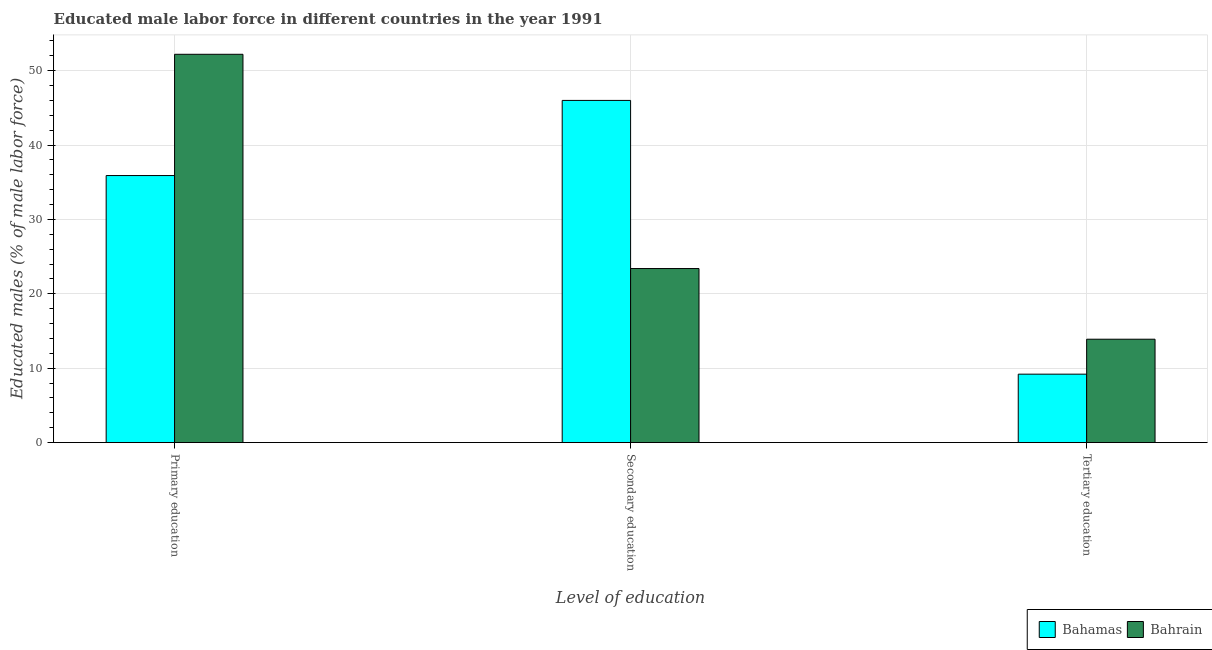How many groups of bars are there?
Ensure brevity in your answer.  3. Are the number of bars on each tick of the X-axis equal?
Make the answer very short. Yes. What is the label of the 3rd group of bars from the left?
Ensure brevity in your answer.  Tertiary education. What is the percentage of male labor force who received secondary education in Bahrain?
Keep it short and to the point. 23.4. Across all countries, what is the maximum percentage of male labor force who received tertiary education?
Your response must be concise. 13.9. Across all countries, what is the minimum percentage of male labor force who received primary education?
Your response must be concise. 35.9. In which country was the percentage of male labor force who received tertiary education maximum?
Ensure brevity in your answer.  Bahrain. In which country was the percentage of male labor force who received primary education minimum?
Your answer should be compact. Bahamas. What is the total percentage of male labor force who received primary education in the graph?
Make the answer very short. 88.1. What is the difference between the percentage of male labor force who received primary education in Bahrain and that in Bahamas?
Your response must be concise. 16.3. What is the difference between the percentage of male labor force who received secondary education in Bahamas and the percentage of male labor force who received tertiary education in Bahrain?
Provide a short and direct response. 32.1. What is the average percentage of male labor force who received primary education per country?
Your answer should be very brief. 44.05. What is the difference between the percentage of male labor force who received tertiary education and percentage of male labor force who received primary education in Bahamas?
Provide a succinct answer. -26.7. In how many countries, is the percentage of male labor force who received tertiary education greater than 46 %?
Give a very brief answer. 0. What is the ratio of the percentage of male labor force who received tertiary education in Bahamas to that in Bahrain?
Your answer should be very brief. 0.66. Is the percentage of male labor force who received secondary education in Bahrain less than that in Bahamas?
Provide a short and direct response. Yes. Is the difference between the percentage of male labor force who received primary education in Bahamas and Bahrain greater than the difference between the percentage of male labor force who received secondary education in Bahamas and Bahrain?
Your answer should be very brief. No. What is the difference between the highest and the second highest percentage of male labor force who received secondary education?
Give a very brief answer. 22.6. What is the difference between the highest and the lowest percentage of male labor force who received secondary education?
Keep it short and to the point. 22.6. What does the 2nd bar from the left in Primary education represents?
Keep it short and to the point. Bahrain. What does the 1st bar from the right in Secondary education represents?
Give a very brief answer. Bahrain. Is it the case that in every country, the sum of the percentage of male labor force who received primary education and percentage of male labor force who received secondary education is greater than the percentage of male labor force who received tertiary education?
Your answer should be very brief. Yes. How many bars are there?
Provide a succinct answer. 6. What is the difference between two consecutive major ticks on the Y-axis?
Offer a terse response. 10. Where does the legend appear in the graph?
Ensure brevity in your answer.  Bottom right. How are the legend labels stacked?
Your response must be concise. Horizontal. What is the title of the graph?
Provide a short and direct response. Educated male labor force in different countries in the year 1991. Does "Sweden" appear as one of the legend labels in the graph?
Offer a terse response. No. What is the label or title of the X-axis?
Your answer should be compact. Level of education. What is the label or title of the Y-axis?
Make the answer very short. Educated males (% of male labor force). What is the Educated males (% of male labor force) in Bahamas in Primary education?
Provide a short and direct response. 35.9. What is the Educated males (% of male labor force) in Bahrain in Primary education?
Offer a very short reply. 52.2. What is the Educated males (% of male labor force) of Bahrain in Secondary education?
Make the answer very short. 23.4. What is the Educated males (% of male labor force) in Bahamas in Tertiary education?
Your answer should be very brief. 9.2. What is the Educated males (% of male labor force) of Bahrain in Tertiary education?
Keep it short and to the point. 13.9. Across all Level of education, what is the maximum Educated males (% of male labor force) of Bahrain?
Offer a very short reply. 52.2. Across all Level of education, what is the minimum Educated males (% of male labor force) of Bahamas?
Provide a short and direct response. 9.2. Across all Level of education, what is the minimum Educated males (% of male labor force) of Bahrain?
Your answer should be very brief. 13.9. What is the total Educated males (% of male labor force) of Bahamas in the graph?
Your answer should be very brief. 91.1. What is the total Educated males (% of male labor force) in Bahrain in the graph?
Make the answer very short. 89.5. What is the difference between the Educated males (% of male labor force) of Bahrain in Primary education and that in Secondary education?
Give a very brief answer. 28.8. What is the difference between the Educated males (% of male labor force) of Bahamas in Primary education and that in Tertiary education?
Your answer should be compact. 26.7. What is the difference between the Educated males (% of male labor force) in Bahrain in Primary education and that in Tertiary education?
Give a very brief answer. 38.3. What is the difference between the Educated males (% of male labor force) of Bahamas in Secondary education and that in Tertiary education?
Provide a succinct answer. 36.8. What is the difference between the Educated males (% of male labor force) in Bahrain in Secondary education and that in Tertiary education?
Offer a terse response. 9.5. What is the difference between the Educated males (% of male labor force) of Bahamas in Primary education and the Educated males (% of male labor force) of Bahrain in Secondary education?
Your response must be concise. 12.5. What is the difference between the Educated males (% of male labor force) in Bahamas in Secondary education and the Educated males (% of male labor force) in Bahrain in Tertiary education?
Make the answer very short. 32.1. What is the average Educated males (% of male labor force) in Bahamas per Level of education?
Ensure brevity in your answer.  30.37. What is the average Educated males (% of male labor force) of Bahrain per Level of education?
Provide a short and direct response. 29.83. What is the difference between the Educated males (% of male labor force) of Bahamas and Educated males (% of male labor force) of Bahrain in Primary education?
Offer a very short reply. -16.3. What is the difference between the Educated males (% of male labor force) of Bahamas and Educated males (% of male labor force) of Bahrain in Secondary education?
Keep it short and to the point. 22.6. What is the difference between the Educated males (% of male labor force) in Bahamas and Educated males (% of male labor force) in Bahrain in Tertiary education?
Your answer should be compact. -4.7. What is the ratio of the Educated males (% of male labor force) of Bahamas in Primary education to that in Secondary education?
Make the answer very short. 0.78. What is the ratio of the Educated males (% of male labor force) of Bahrain in Primary education to that in Secondary education?
Offer a very short reply. 2.23. What is the ratio of the Educated males (% of male labor force) of Bahamas in Primary education to that in Tertiary education?
Keep it short and to the point. 3.9. What is the ratio of the Educated males (% of male labor force) in Bahrain in Primary education to that in Tertiary education?
Ensure brevity in your answer.  3.76. What is the ratio of the Educated males (% of male labor force) in Bahrain in Secondary education to that in Tertiary education?
Offer a terse response. 1.68. What is the difference between the highest and the second highest Educated males (% of male labor force) of Bahrain?
Offer a terse response. 28.8. What is the difference between the highest and the lowest Educated males (% of male labor force) of Bahamas?
Your answer should be very brief. 36.8. What is the difference between the highest and the lowest Educated males (% of male labor force) in Bahrain?
Provide a succinct answer. 38.3. 